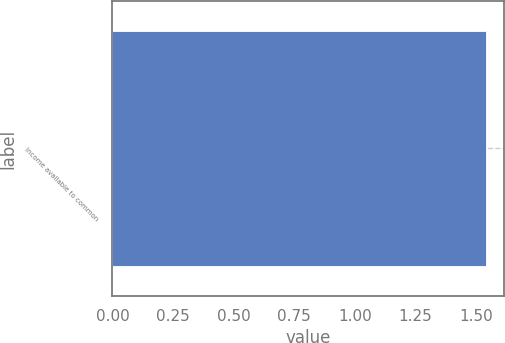Convert chart. <chart><loc_0><loc_0><loc_500><loc_500><bar_chart><fcel>Income available to common<nl><fcel>1.54<nl></chart> 